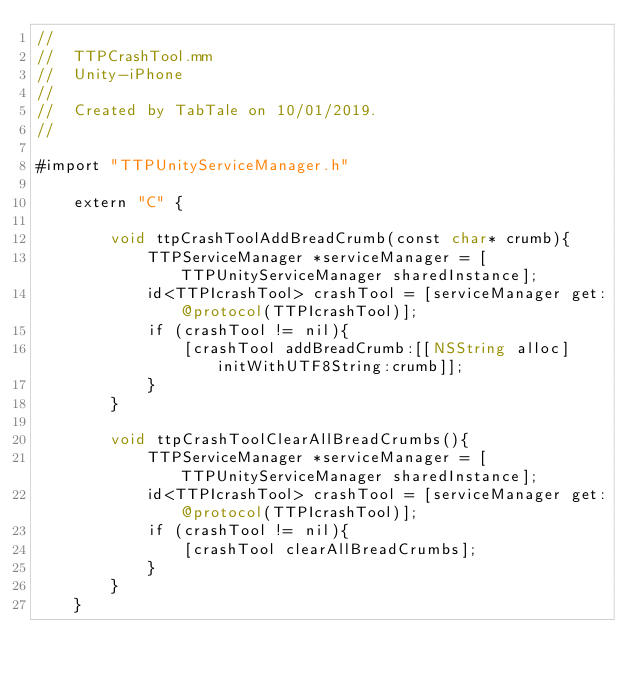Convert code to text. <code><loc_0><loc_0><loc_500><loc_500><_ObjectiveC_>//
//  TTPCrashTool.mm
//  Unity-iPhone
//
//  Created by TabTale on 10/01/2019.
//

#import "TTPUnityServiceManager.h"

    extern "C" {
        
        void ttpCrashToolAddBreadCrumb(const char* crumb){
            TTPServiceManager *serviceManager = [TTPUnityServiceManager sharedInstance];
            id<TTPIcrashTool> crashTool = [serviceManager get:@protocol(TTPIcrashTool)];
            if (crashTool != nil){
                [crashTool addBreadCrumb:[[NSString alloc] initWithUTF8String:crumb]];
            }
        }
        
        void ttpCrashToolClearAllBreadCrumbs(){
            TTPServiceManager *serviceManager = [TTPUnityServiceManager sharedInstance];
            id<TTPIcrashTool> crashTool = [serviceManager get:@protocol(TTPIcrashTool)];
            if (crashTool != nil){
                [crashTool clearAllBreadCrumbs];
            }
        }
    }

</code> 